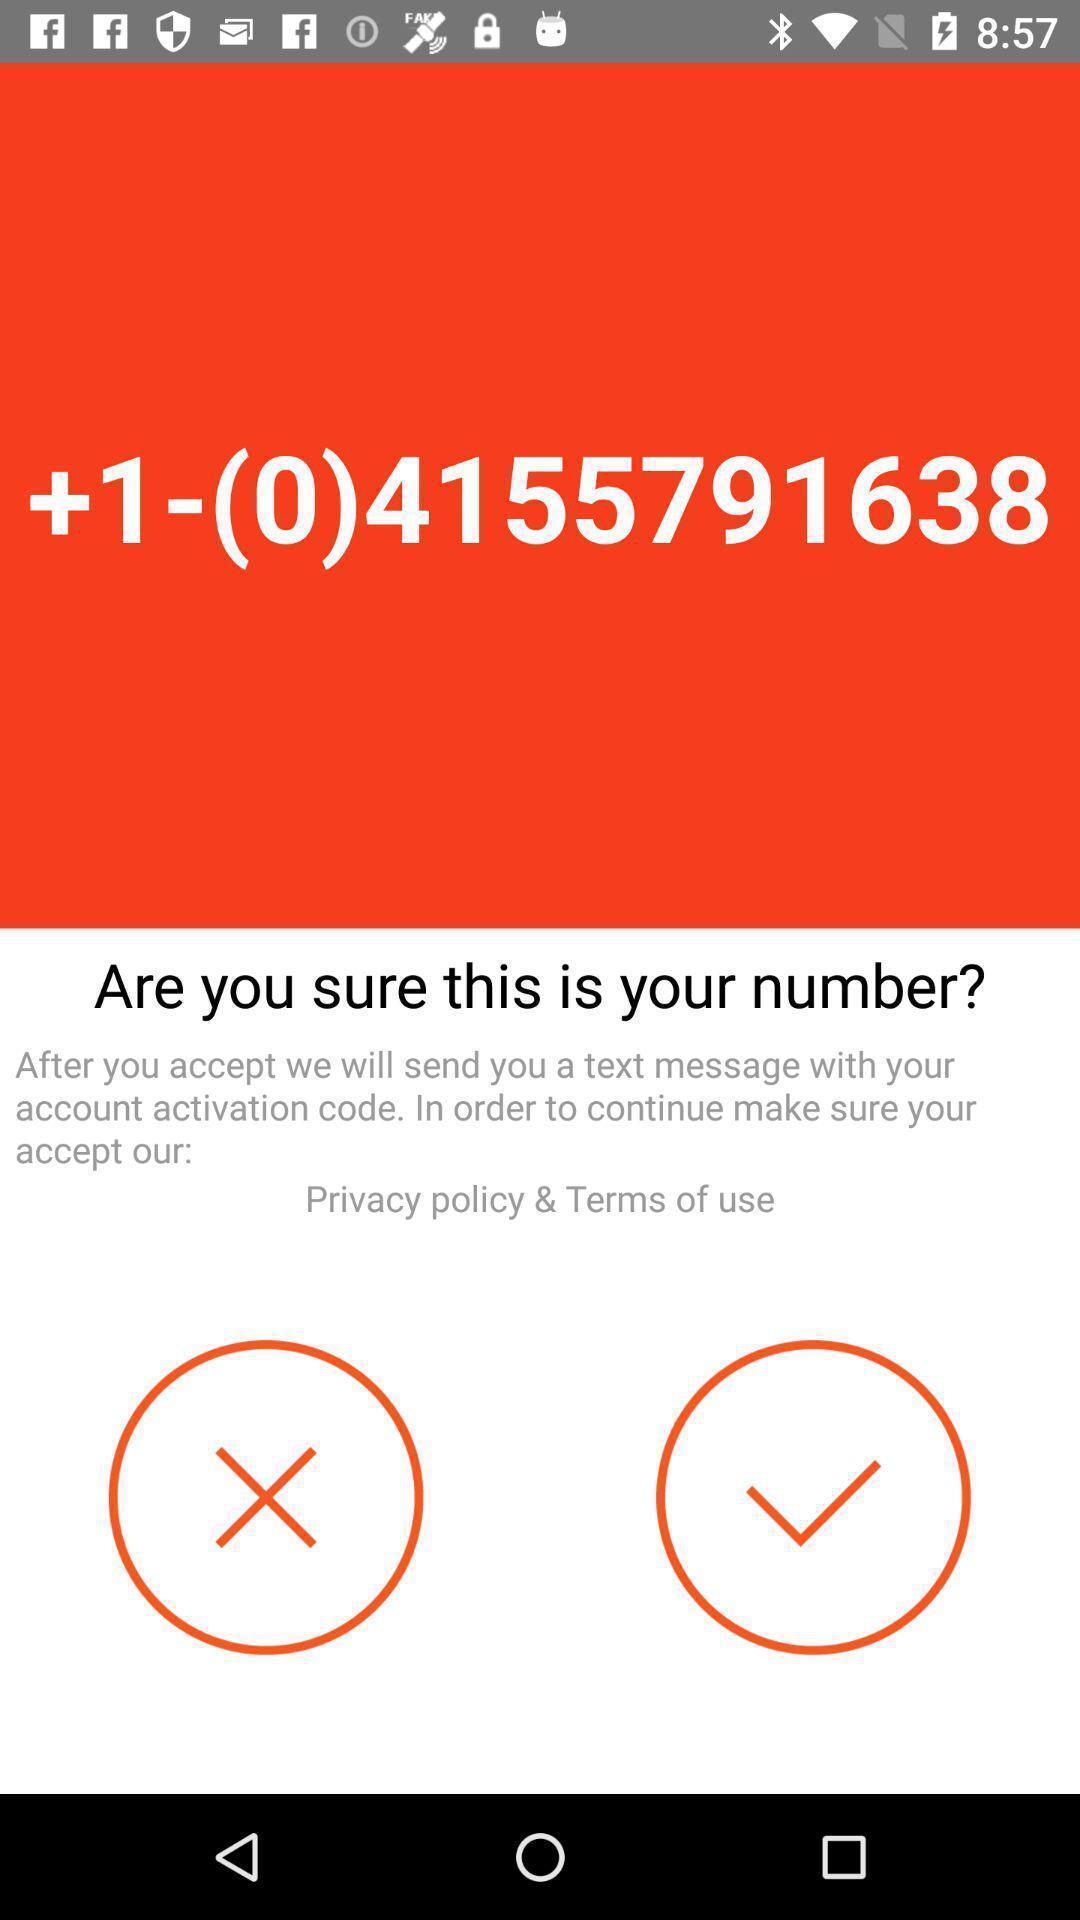Describe the content in this image. Screen displaying the confirmation of number. 